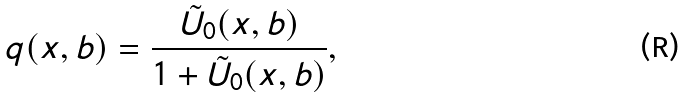<formula> <loc_0><loc_0><loc_500><loc_500>q ( x , b ) = \frac { \tilde { U } _ { 0 } ( x , b ) } { 1 + \tilde { U } _ { 0 } ( x , b ) } ,</formula> 